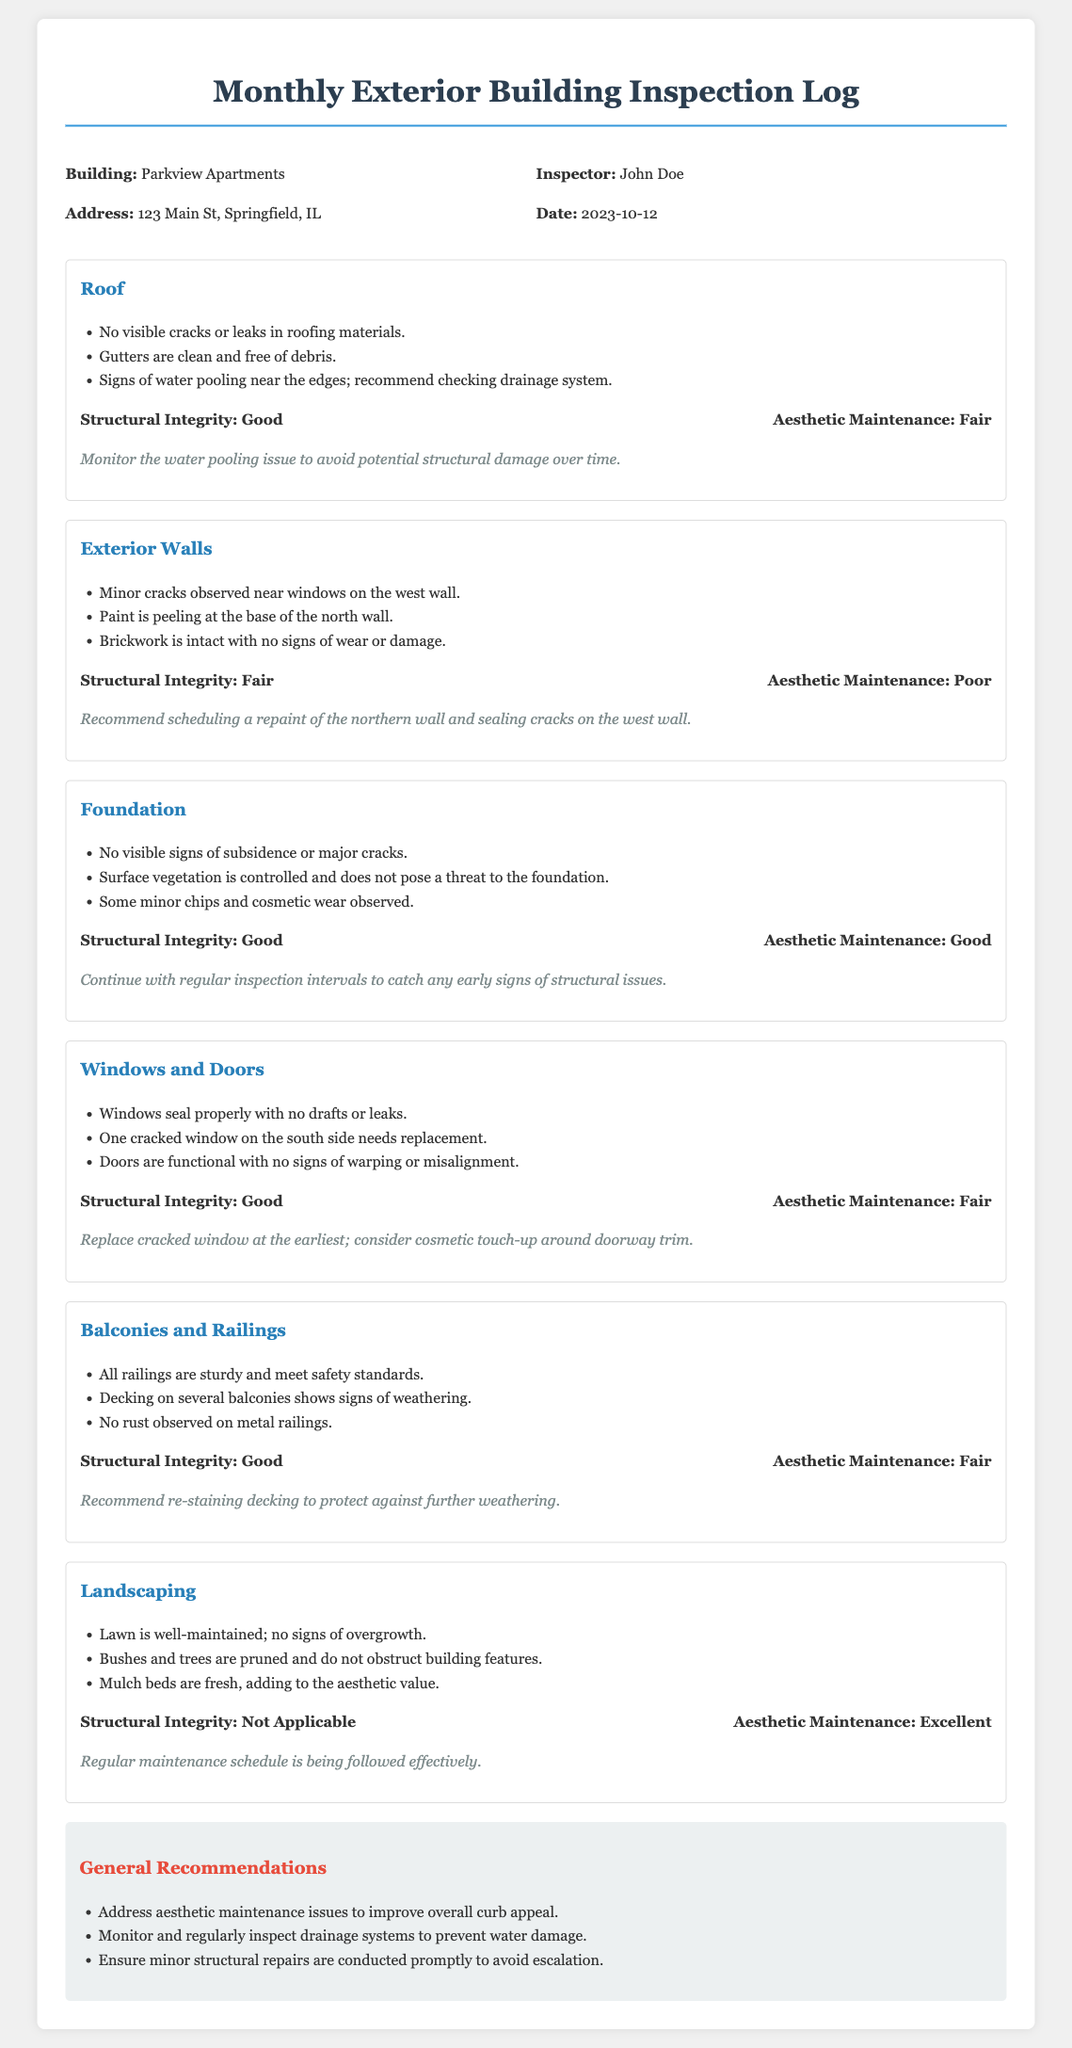What is the building name? The building name is mentioned in the header section of the document.
Answer: Parkview Apartments Who is the inspector? The name of the inspector is provided in the document's header information.
Answer: John Doe What date was the inspection conducted? The inspection date is located in the header information of the document.
Answer: 2023-10-12 What is the structural integrity rating for Exterior Walls? The structural integrity rating for Exterior Walls is stated in the section dedicated to it.
Answer: Fair What aesthetic maintenance issue was identified for the balconies and railings? The aesthetic maintenance issue is mentioned in the section for balconies and railings, specifically regarding decking.
Answer: Weathering How many recommendations are listed in the general recommendations section? The number of recommendations can be counted from the list provided.
Answer: Three What specific window issue was noted in the Windows and Doors section? The specific window issue is detailed in the relevant section.
Answer: One cracked window on the south side needs replacement What is the aesthetic maintenance rating for Landscaping? The aesthetic maintenance rating for Landscaping is found in the corresponding section.
Answer: Excellent What is recommended for the northern wall? The recommendation can be found in the notes section for the Exterior Walls.
Answer: Scheduling a repaint 